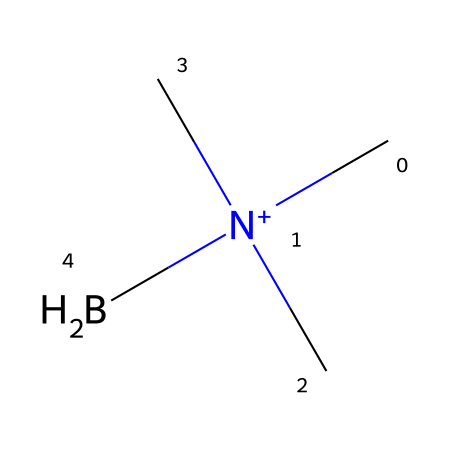What is the molecular formula of trimethylamine-borane? The chemical is made up of three methyl groups (CH3) bonded to a nitrogen atom (N) and one boron atom (B). Counting the total elements gives C3H12N1B1.
Answer: C3H12BN How many carbon atoms are present in the structure? The structure shows three methyl groups, each contributing one carbon atom. Therefore, there are three carbon atoms in total.
Answer: 3 Which atom in this structure is the Lewis acid? The boron atom (B) has an incomplete octet and can accept electron pairs, making it the Lewis acid in this adduct.
Answer: B What is the charge on the nitrogen atom in trimethylamine-borane? The nitrogen atom is quaternized in this structure (having four bonds), which gives it a positive charge as it has one more bond than it typically would (three).
Answer: +1 How many hydrogen atoms are bound to the nitrogen atom? The nitrogen atom in trimethylamine-borane is bonded to three carbon atoms (from the three methyl groups), without any additional hydrogen atom attached to it, leading to zero hydrogen atoms extra bound directly to nitrogen.
Answer: 0 What type of bonding characterizes the interaction between trimethylamine and borane? The bonding between trimethylamine and borane is largely characterized by coordinate covalent bonding, where the nitrogen donates a pair of electrons to boron, thus forming the adduct.
Answer: coordinate covalent 